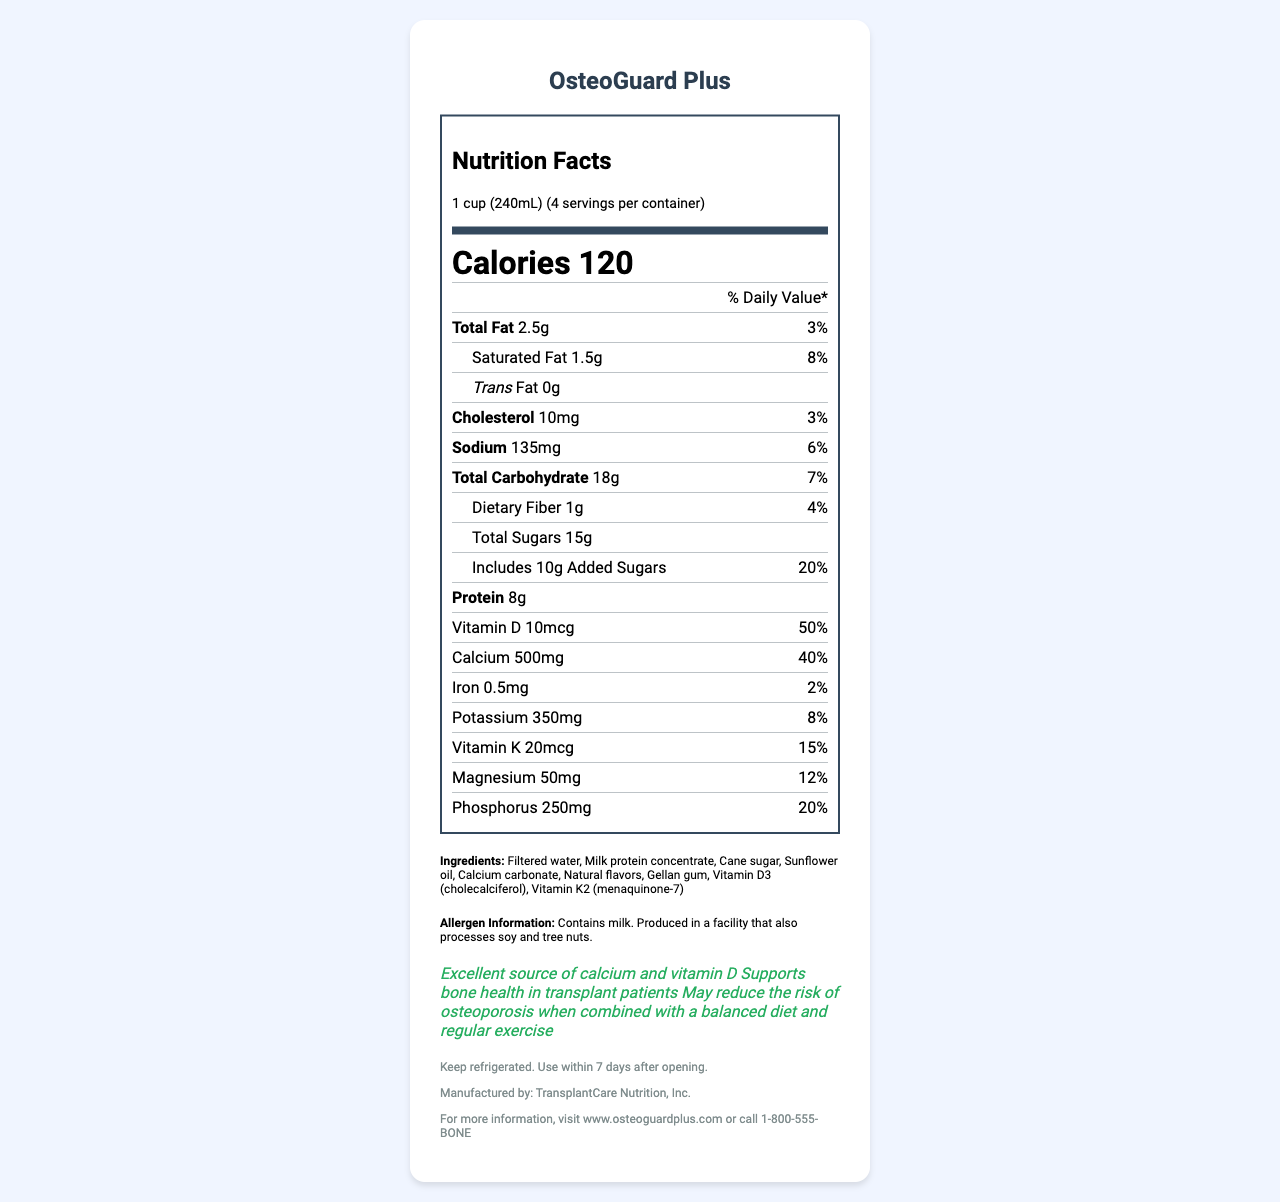what is the serving size of OsteoGuard Plus? The serving size is explicitly mentioned at the beginning of the nutrition facts label.
Answer: 1 cup (240mL) how many servings are there per container of OsteoGuard Plus? The servings per container are listed immediately following the serving size information.
Answer: 4 what is the total amount of carbohydrates in one serving of OsteoGuard Plus? The total carbohydrate content is listed in the nutrient section of the nutrition facts label.
Answer: 18g what is the percentage of daily value (%DV) for calcium in one serving of OsteoGuard Plus? The %DV for calcium is specified in the nutrient section of the label.
Answer: 40% how many calories are in one serving of OsteoGuard Plus? The number of calories is prominently displayed in the nutrition facts label.
Answer: 120 which ingredient is present in OsteoGuard Plus? A. Soy Protein Isolate B. Milk Protein Concentrate C. Almond Extract Milk Protein Concentrate is listed among the ingredients while Soy Protein Isolate and Almond Extract are not.
Answer: B what is the amount of Vitamin D in one serving of OsteoGuard Plus? A. 5mcg B. 10mcg C. 15mcg The amount of Vitamin D in one serving is 10mcg.
Answer: B is there any trans fat in OsteoGuard Plus? The label clearly states that there is 0g of trans fat per serving.
Answer: No does OsteoGuard Plus contain any allergens? The label mentions it contains milk and is produced in a facility that also processes soy and tree nuts.
Answer: Yes summarize the health claims made about OsteoGuard Plus. These claims are listed in the health claims section of the label.
Answer: OsteoGuard Plus is an excellent source of calcium and vitamin D, supports bone health in transplant patients, and may reduce the risk of osteoporosis when combined with a balanced diet and regular exercise. where should OsteoGuard Plus be stored? The storage instructions specify to keep the product refrigerated and use within 7 days after opening.
Answer: Refrigerated what is the total fat content in one serving of OsteoGuard Plus? The total fat content is listed on the nutrition facts label.
Answer: 2.5g if the recommended daily value for iron is 100%, how much iron is in one serving of OsteoGuard Plus? The document states that each serving provides 0.5mg of iron, which is 2% of the recommended daily value.
Answer: 0.5% what is the sodium content per serving? The sodium content is clearly specified on the nutrition facts label.
Answer: 135mg is it possible to determine the manufacturing date of OsteoGuard Plus from the document? The document does not provide any information related to the manufacturing date.
Answer: Cannot be determined 